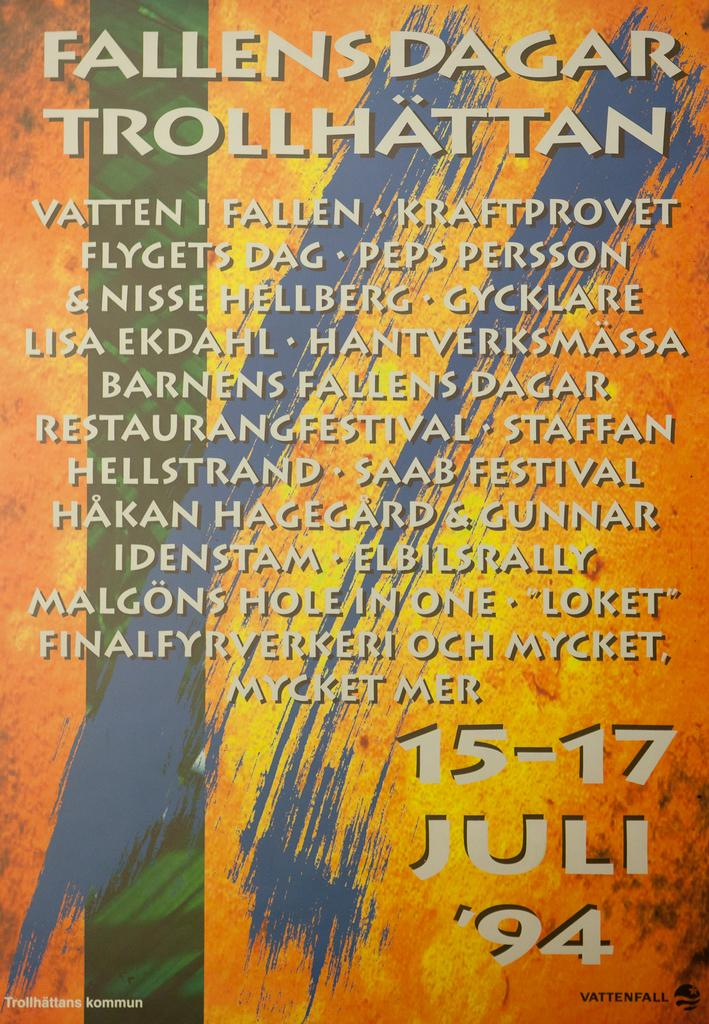<image>
Write a terse but informative summary of the picture. The Fallensdagar Trollhattan book cover from July 1994. 